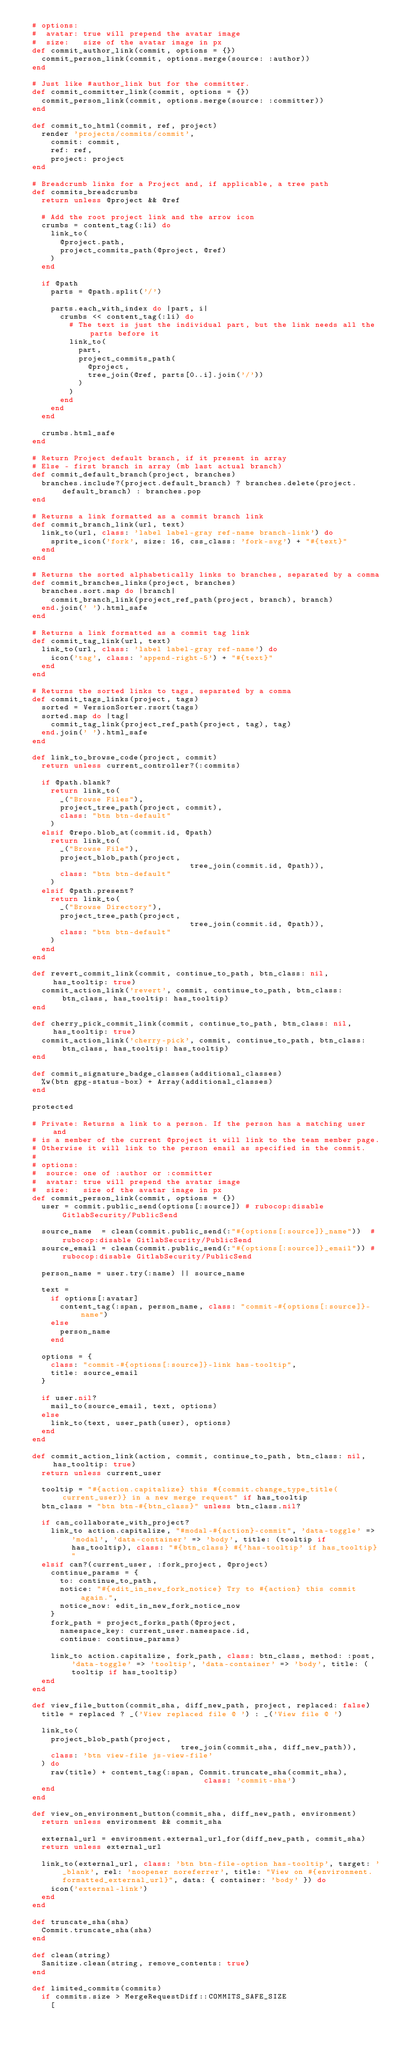Convert code to text. <code><loc_0><loc_0><loc_500><loc_500><_Ruby_>  # options:
  #  avatar: true will prepend the avatar image
  #  size:   size of the avatar image in px
  def commit_author_link(commit, options = {})
    commit_person_link(commit, options.merge(source: :author))
  end

  # Just like #author_link but for the committer.
  def commit_committer_link(commit, options = {})
    commit_person_link(commit, options.merge(source: :committer))
  end

  def commit_to_html(commit, ref, project)
    render 'projects/commits/commit',
      commit: commit,
      ref: ref,
      project: project
  end

  # Breadcrumb links for a Project and, if applicable, a tree path
  def commits_breadcrumbs
    return unless @project && @ref

    # Add the root project link and the arrow icon
    crumbs = content_tag(:li) do
      link_to(
        @project.path,
        project_commits_path(@project, @ref)
      )
    end

    if @path
      parts = @path.split('/')

      parts.each_with_index do |part, i|
        crumbs << content_tag(:li) do
          # The text is just the individual part, but the link needs all the parts before it
          link_to(
            part,
            project_commits_path(
              @project,
              tree_join(@ref, parts[0..i].join('/'))
            )
          )
        end
      end
    end

    crumbs.html_safe
  end

  # Return Project default branch, if it present in array
  # Else - first branch in array (mb last actual branch)
  def commit_default_branch(project, branches)
    branches.include?(project.default_branch) ? branches.delete(project.default_branch) : branches.pop
  end

  # Returns a link formatted as a commit branch link
  def commit_branch_link(url, text)
    link_to(url, class: 'label label-gray ref-name branch-link') do
      sprite_icon('fork', size: 16, css_class: 'fork-svg') + "#{text}"
    end
  end

  # Returns the sorted alphabetically links to branches, separated by a comma
  def commit_branches_links(project, branches)
    branches.sort.map do |branch|
      commit_branch_link(project_ref_path(project, branch), branch)
    end.join(' ').html_safe
  end

  # Returns a link formatted as a commit tag link
  def commit_tag_link(url, text)
    link_to(url, class: 'label label-gray ref-name') do
      icon('tag', class: 'append-right-5') + "#{text}"
    end
  end

  # Returns the sorted links to tags, separated by a comma
  def commit_tags_links(project, tags)
    sorted = VersionSorter.rsort(tags)
    sorted.map do |tag|
      commit_tag_link(project_ref_path(project, tag), tag)
    end.join(' ').html_safe
  end

  def link_to_browse_code(project, commit)
    return unless current_controller?(:commits)

    if @path.blank?
      return link_to(
        _("Browse Files"),
        project_tree_path(project, commit),
        class: "btn btn-default"
      )
    elsif @repo.blob_at(commit.id, @path)
      return link_to(
        _("Browse File"),
        project_blob_path(project,
                                    tree_join(commit.id, @path)),
        class: "btn btn-default"
      )
    elsif @path.present?
      return link_to(
        _("Browse Directory"),
        project_tree_path(project,
                                    tree_join(commit.id, @path)),
        class: "btn btn-default"
      )
    end
  end

  def revert_commit_link(commit, continue_to_path, btn_class: nil, has_tooltip: true)
    commit_action_link('revert', commit, continue_to_path, btn_class: btn_class, has_tooltip: has_tooltip)
  end

  def cherry_pick_commit_link(commit, continue_to_path, btn_class: nil, has_tooltip: true)
    commit_action_link('cherry-pick', commit, continue_to_path, btn_class: btn_class, has_tooltip: has_tooltip)
  end

  def commit_signature_badge_classes(additional_classes)
    %w(btn gpg-status-box) + Array(additional_classes)
  end

  protected

  # Private: Returns a link to a person. If the person has a matching user and
  # is a member of the current @project it will link to the team member page.
  # Otherwise it will link to the person email as specified in the commit.
  #
  # options:
  #  source: one of :author or :committer
  #  avatar: true will prepend the avatar image
  #  size:   size of the avatar image in px
  def commit_person_link(commit, options = {})
    user = commit.public_send(options[:source]) # rubocop:disable GitlabSecurity/PublicSend

    source_name  = clean(commit.public_send(:"#{options[:source]}_name"))  # rubocop:disable GitlabSecurity/PublicSend
    source_email = clean(commit.public_send(:"#{options[:source]}_email")) # rubocop:disable GitlabSecurity/PublicSend

    person_name = user.try(:name) || source_name

    text =
      if options[:avatar]
        content_tag(:span, person_name, class: "commit-#{options[:source]}-name")
      else
        person_name
      end

    options = {
      class: "commit-#{options[:source]}-link has-tooltip",
      title: source_email
    }

    if user.nil?
      mail_to(source_email, text, options)
    else
      link_to(text, user_path(user), options)
    end
  end

  def commit_action_link(action, commit, continue_to_path, btn_class: nil, has_tooltip: true)
    return unless current_user

    tooltip = "#{action.capitalize} this #{commit.change_type_title(current_user)} in a new merge request" if has_tooltip
    btn_class = "btn btn-#{btn_class}" unless btn_class.nil?

    if can_collaborate_with_project?
      link_to action.capitalize, "#modal-#{action}-commit", 'data-toggle' => 'modal', 'data-container' => 'body', title: (tooltip if has_tooltip), class: "#{btn_class} #{'has-tooltip' if has_tooltip}"
    elsif can?(current_user, :fork_project, @project)
      continue_params = {
        to: continue_to_path,
        notice: "#{edit_in_new_fork_notice} Try to #{action} this commit again.",
        notice_now: edit_in_new_fork_notice_now
      }
      fork_path = project_forks_path(@project,
        namespace_key: current_user.namespace.id,
        continue: continue_params)

      link_to action.capitalize, fork_path, class: btn_class, method: :post, 'data-toggle' => 'tooltip', 'data-container' => 'body', title: (tooltip if has_tooltip)
    end
  end

  def view_file_button(commit_sha, diff_new_path, project, replaced: false)
    title = replaced ? _('View replaced file @ ') : _('View file @ ')

    link_to(
      project_blob_path(project,
                                  tree_join(commit_sha, diff_new_path)),
      class: 'btn view-file js-view-file'
    ) do
      raw(title) + content_tag(:span, Commit.truncate_sha(commit_sha),
                                       class: 'commit-sha')
    end
  end

  def view_on_environment_button(commit_sha, diff_new_path, environment)
    return unless environment && commit_sha

    external_url = environment.external_url_for(diff_new_path, commit_sha)
    return unless external_url

    link_to(external_url, class: 'btn btn-file-option has-tooltip', target: '_blank', rel: 'noopener noreferrer', title: "View on #{environment.formatted_external_url}", data: { container: 'body' }) do
      icon('external-link')
    end
  end

  def truncate_sha(sha)
    Commit.truncate_sha(sha)
  end

  def clean(string)
    Sanitize.clean(string, remove_contents: true)
  end

  def limited_commits(commits)
    if commits.size > MergeRequestDiff::COMMITS_SAFE_SIZE
      [</code> 